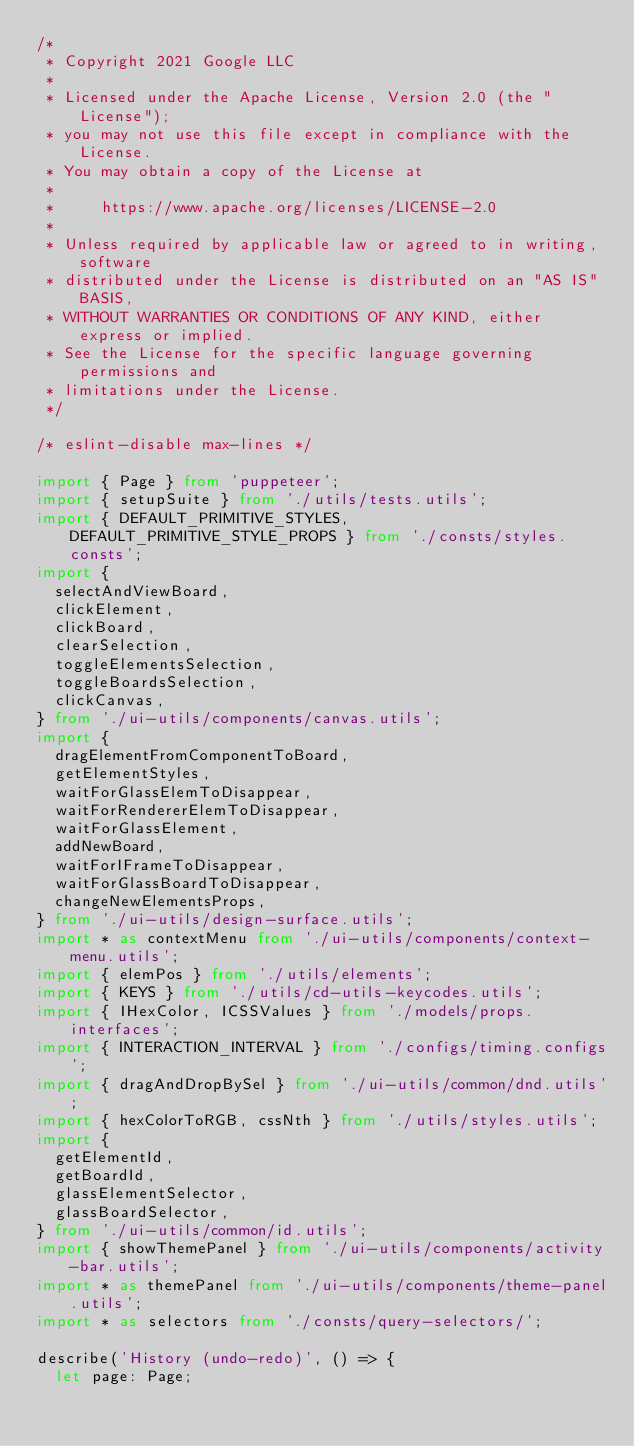Convert code to text. <code><loc_0><loc_0><loc_500><loc_500><_TypeScript_>/*
 * Copyright 2021 Google LLC
 *
 * Licensed under the Apache License, Version 2.0 (the "License");
 * you may not use this file except in compliance with the License.
 * You may obtain a copy of the License at
 *
 *     https://www.apache.org/licenses/LICENSE-2.0
 *
 * Unless required by applicable law or agreed to in writing, software
 * distributed under the License is distributed on an "AS IS" BASIS,
 * WITHOUT WARRANTIES OR CONDITIONS OF ANY KIND, either express or implied.
 * See the License for the specific language governing permissions and
 * limitations under the License.
 */

/* eslint-disable max-lines */

import { Page } from 'puppeteer';
import { setupSuite } from './utils/tests.utils';
import { DEFAULT_PRIMITIVE_STYLES, DEFAULT_PRIMITIVE_STYLE_PROPS } from './consts/styles.consts';
import {
  selectAndViewBoard,
  clickElement,
  clickBoard,
  clearSelection,
  toggleElementsSelection,
  toggleBoardsSelection,
  clickCanvas,
} from './ui-utils/components/canvas.utils';
import {
  dragElementFromComponentToBoard,
  getElementStyles,
  waitForGlassElemToDisappear,
  waitForRendererElemToDisappear,
  waitForGlassElement,
  addNewBoard,
  waitForIFrameToDisappear,
  waitForGlassBoardToDisappear,
  changeNewElementsProps,
} from './ui-utils/design-surface.utils';
import * as contextMenu from './ui-utils/components/context-menu.utils';
import { elemPos } from './utils/elements';
import { KEYS } from './utils/cd-utils-keycodes.utils';
import { IHexColor, ICSSValues } from './models/props.interfaces';
import { INTERACTION_INTERVAL } from './configs/timing.configs';
import { dragAndDropBySel } from './ui-utils/common/dnd.utils';
import { hexColorToRGB, cssNth } from './utils/styles.utils';
import {
  getElementId,
  getBoardId,
  glassElementSelector,
  glassBoardSelector,
} from './ui-utils/common/id.utils';
import { showThemePanel } from './ui-utils/components/activity-bar.utils';
import * as themePanel from './ui-utils/components/theme-panel.utils';
import * as selectors from './consts/query-selectors/';

describe('History (undo-redo)', () => {
  let page: Page;
</code> 